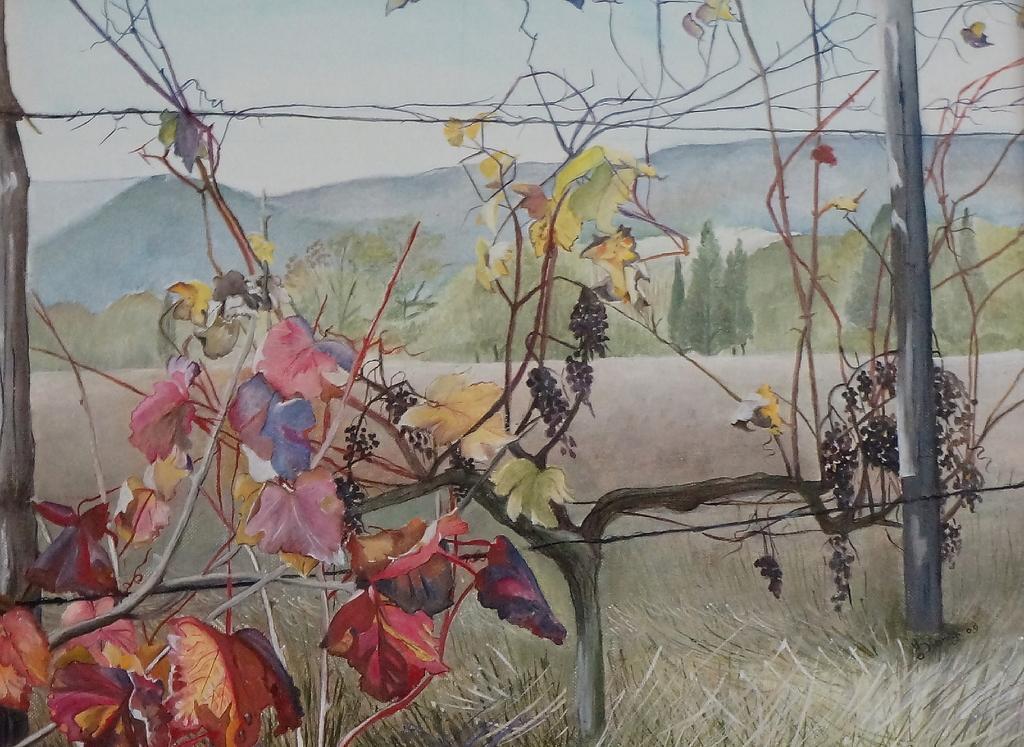Describe this image in one or two sentences. In this image I can see a painting of plants and a fencing with a barbed wire. At the bottom, I can see the grass. In the background there are many trees and hills. At the top of the image I can see the sky. 